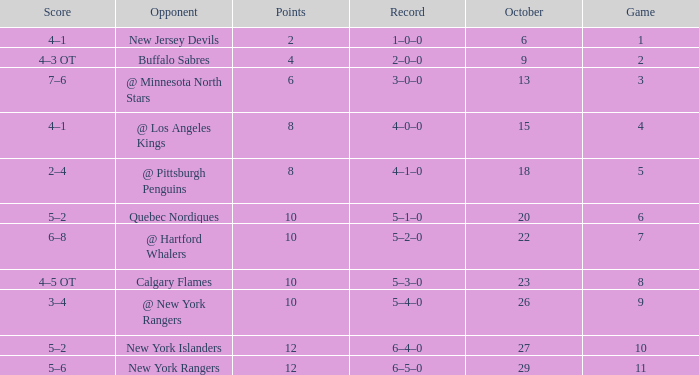How many Points have an Opponent of @ los angeles kings and a Game larger than 4? None. 